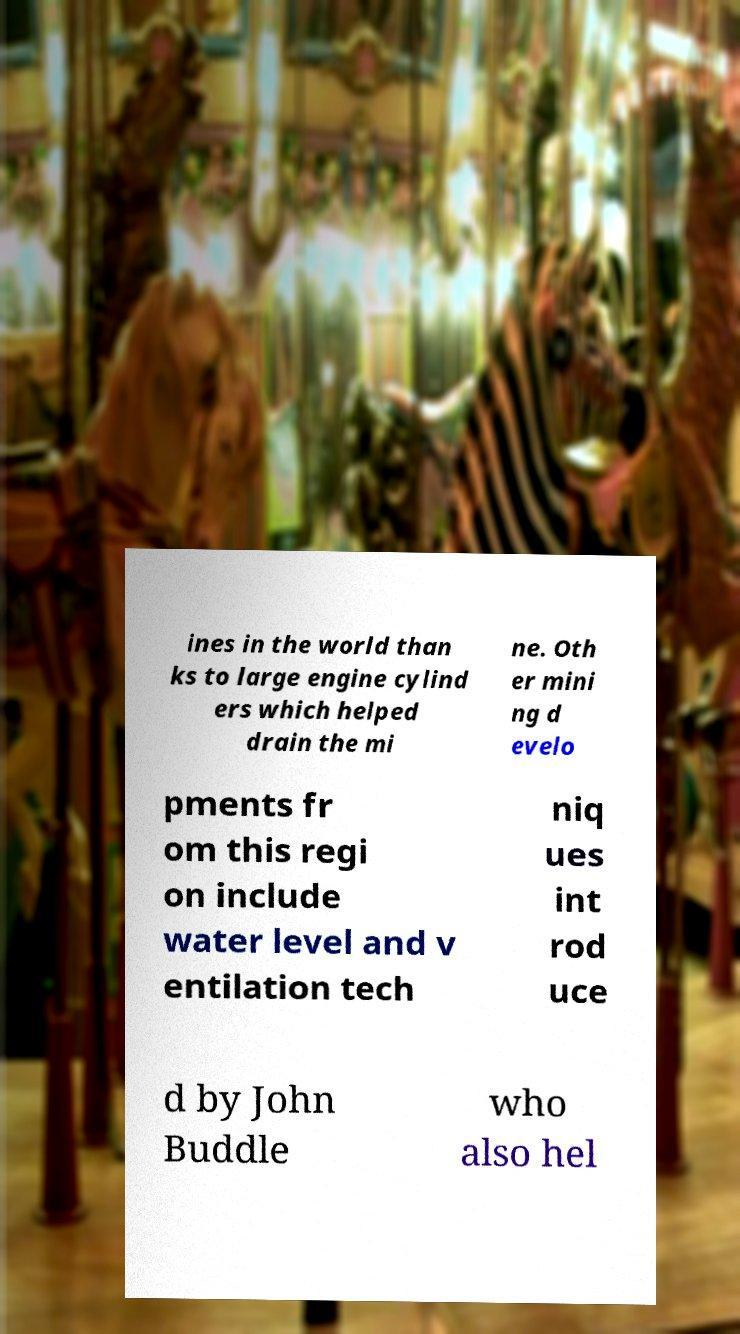Could you extract and type out the text from this image? ines in the world than ks to large engine cylind ers which helped drain the mi ne. Oth er mini ng d evelo pments fr om this regi on include water level and v entilation tech niq ues int rod uce d by John Buddle who also hel 